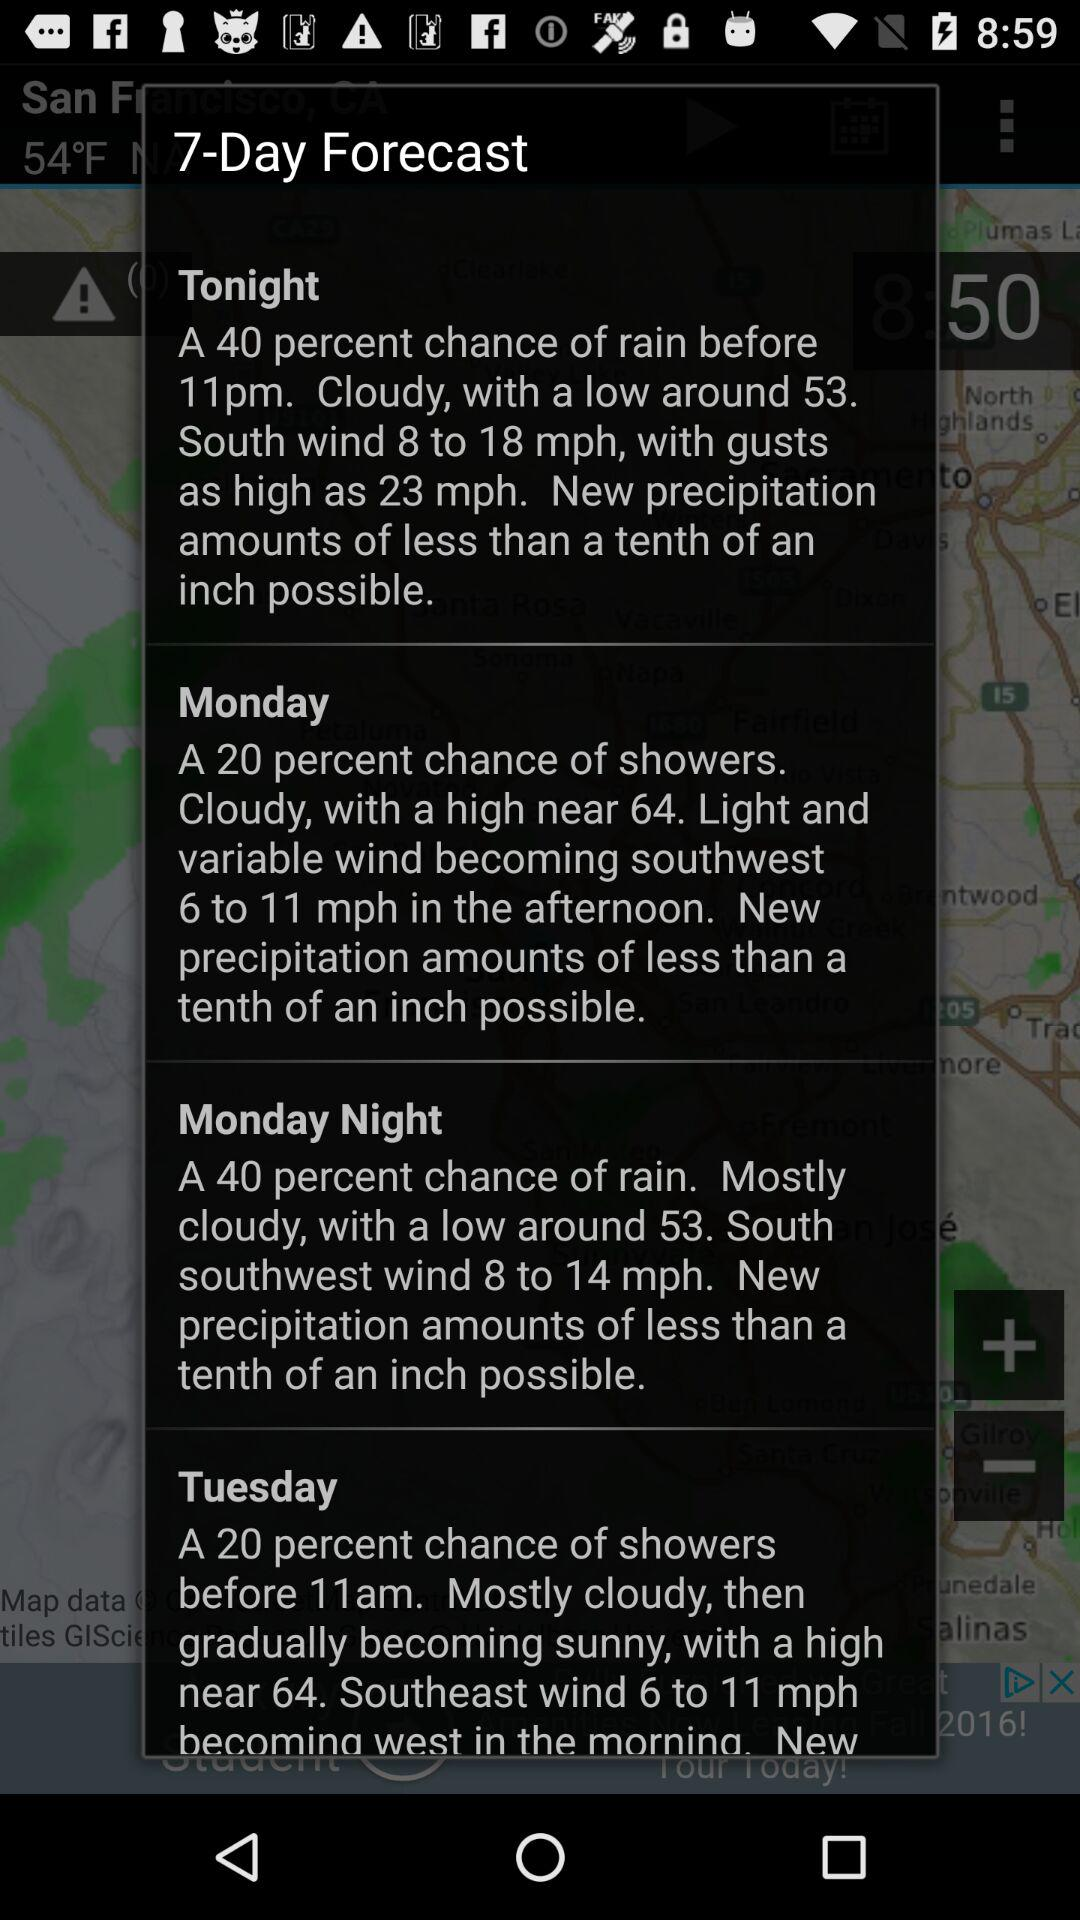For how many days is the forecast? The forecast is for 7 days. 